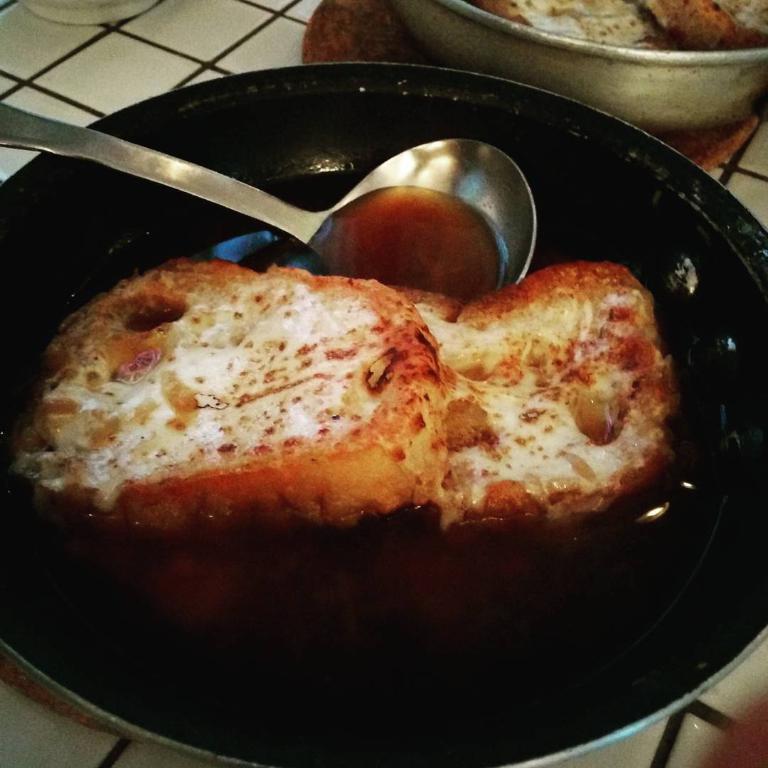Please provide a concise description of this image. In this picture we can see food and a spoon in the bowl. 